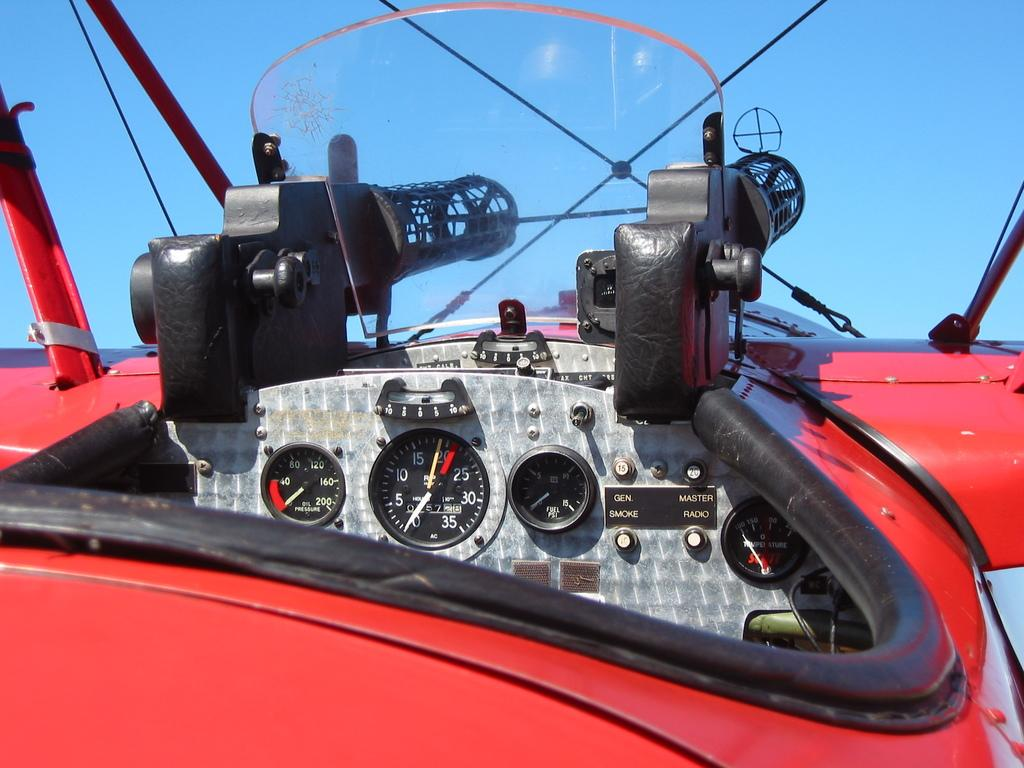What type of vehicle is shown in the image? The image shows an inner view of a vehicle, but the specific type cannot be determined from the provided facts. What can be seen outside the vehicle in the image? The sky is visible in the image. How many toes are visible in the image? There are no toes visible in the image, as it shows an inner view of a vehicle. What process is being carried out in the image? The image does not depict any specific process; it simply shows an inner view of a vehicle with the sky visible outside. 